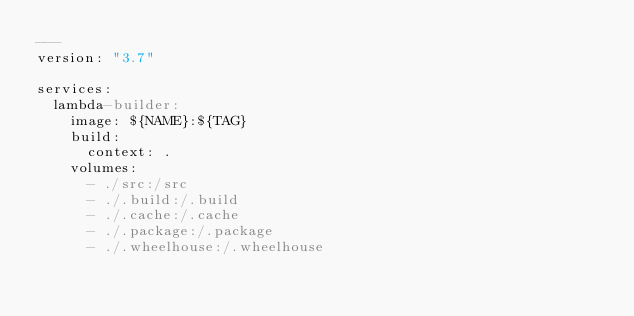<code> <loc_0><loc_0><loc_500><loc_500><_YAML_>---
version: "3.7"

services:
  lambda-builder:
    image: ${NAME}:${TAG}
    build:
      context: .
    volumes:
      - ./src:/src
      - ./.build:/.build
      - ./.cache:/.cache
      - ./.package:/.package
      - ./.wheelhouse:/.wheelhouse
</code> 